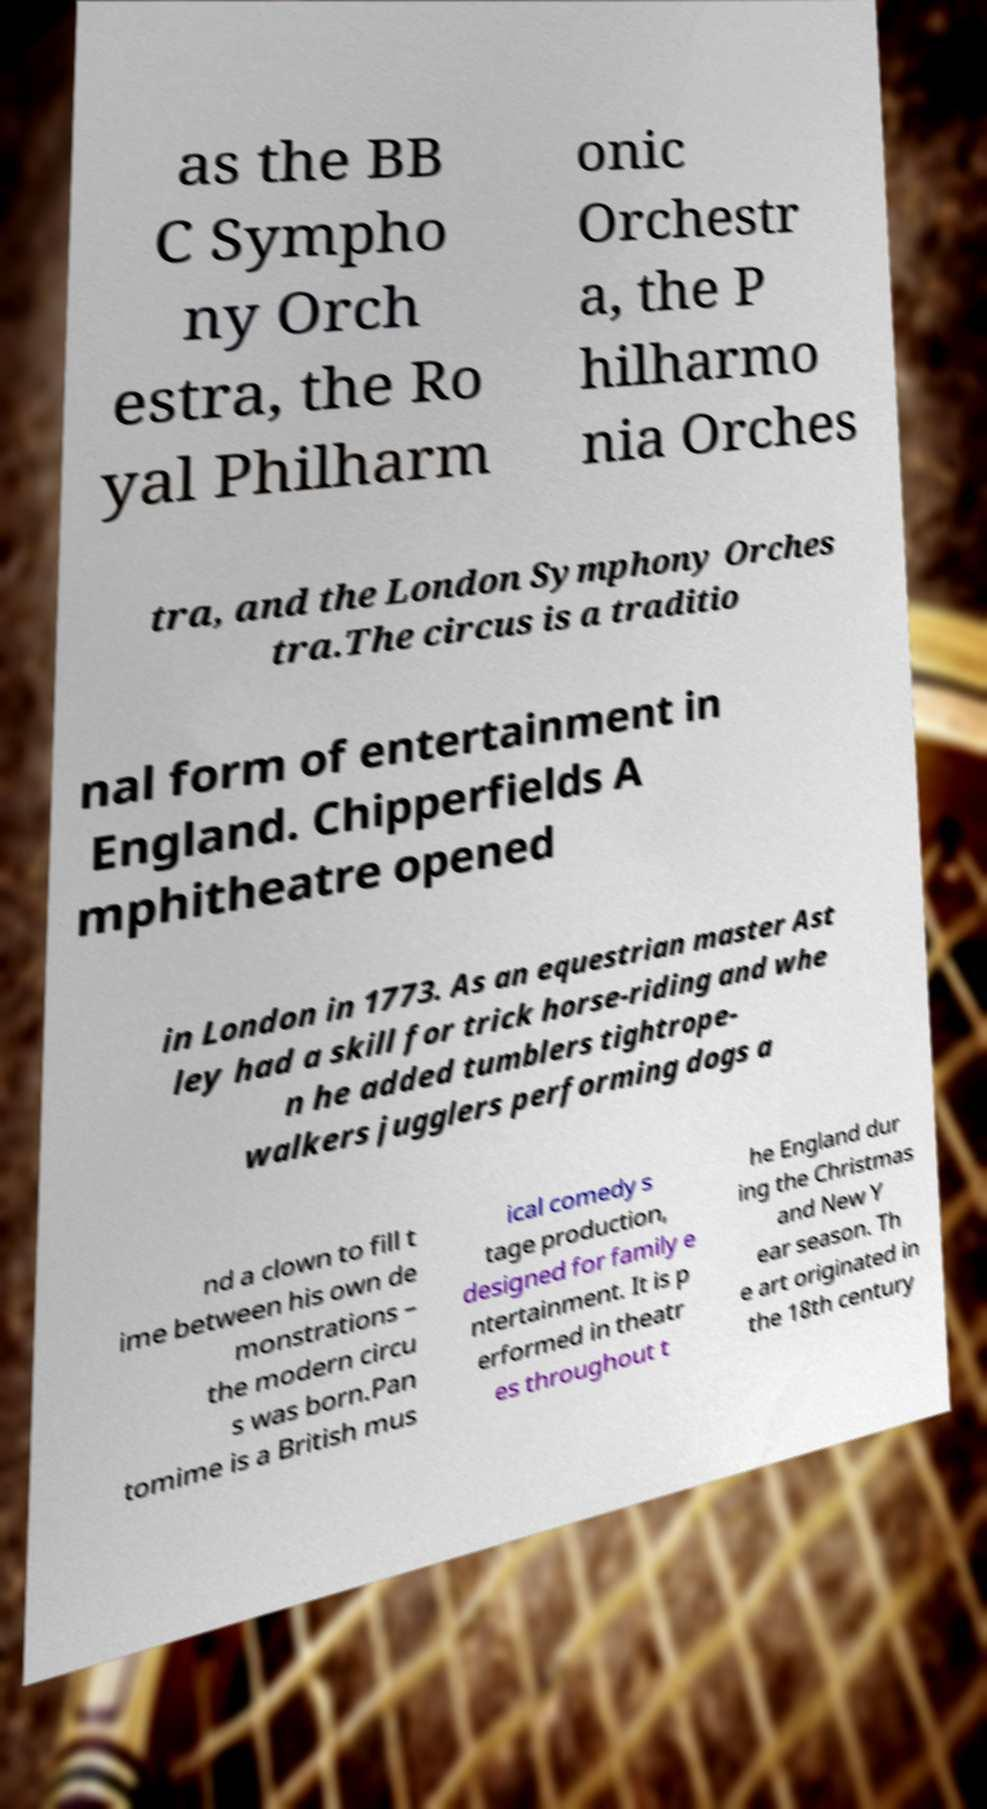For documentation purposes, I need the text within this image transcribed. Could you provide that? as the BB C Sympho ny Orch estra, the Ro yal Philharm onic Orchestr a, the P hilharmo nia Orches tra, and the London Symphony Orches tra.The circus is a traditio nal form of entertainment in England. Chipperfields A mphitheatre opened in London in 1773. As an equestrian master Ast ley had a skill for trick horse-riding and whe n he added tumblers tightrope- walkers jugglers performing dogs a nd a clown to fill t ime between his own de monstrations – the modern circu s was born.Pan tomime is a British mus ical comedy s tage production, designed for family e ntertainment. It is p erformed in theatr es throughout t he England dur ing the Christmas and New Y ear season. Th e art originated in the 18th century 